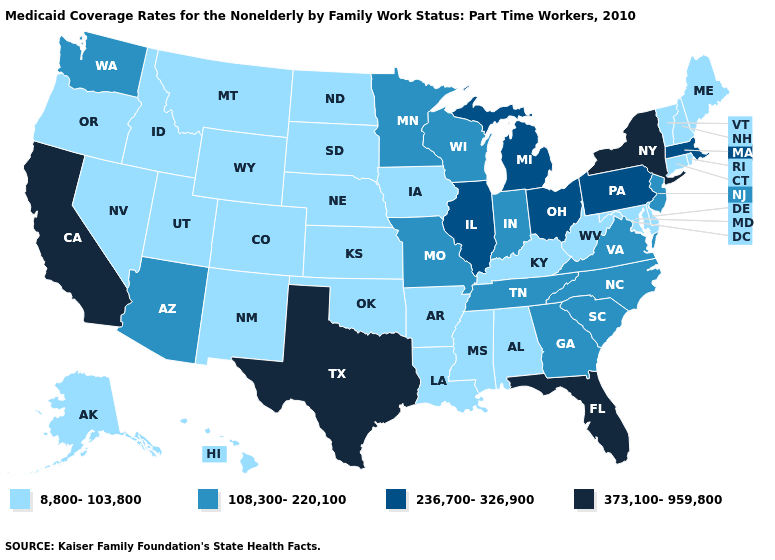What is the lowest value in states that border Massachusetts?
Short answer required. 8,800-103,800. Does New York have the highest value in the USA?
Give a very brief answer. Yes. Name the states that have a value in the range 108,300-220,100?
Be succinct. Arizona, Georgia, Indiana, Minnesota, Missouri, New Jersey, North Carolina, South Carolina, Tennessee, Virginia, Washington, Wisconsin. What is the value of Colorado?
Write a very short answer. 8,800-103,800. Which states have the highest value in the USA?
Keep it brief. California, Florida, New York, Texas. Does the first symbol in the legend represent the smallest category?
Answer briefly. Yes. What is the value of Oklahoma?
Short answer required. 8,800-103,800. Name the states that have a value in the range 108,300-220,100?
Be succinct. Arizona, Georgia, Indiana, Minnesota, Missouri, New Jersey, North Carolina, South Carolina, Tennessee, Virginia, Washington, Wisconsin. Name the states that have a value in the range 236,700-326,900?
Be succinct. Illinois, Massachusetts, Michigan, Ohio, Pennsylvania. What is the highest value in the West ?
Be succinct. 373,100-959,800. Name the states that have a value in the range 373,100-959,800?
Keep it brief. California, Florida, New York, Texas. What is the value of New Hampshire?
Short answer required. 8,800-103,800. Does California have the highest value in the West?
Short answer required. Yes. What is the value of Wisconsin?
Give a very brief answer. 108,300-220,100. What is the value of Colorado?
Concise answer only. 8,800-103,800. 